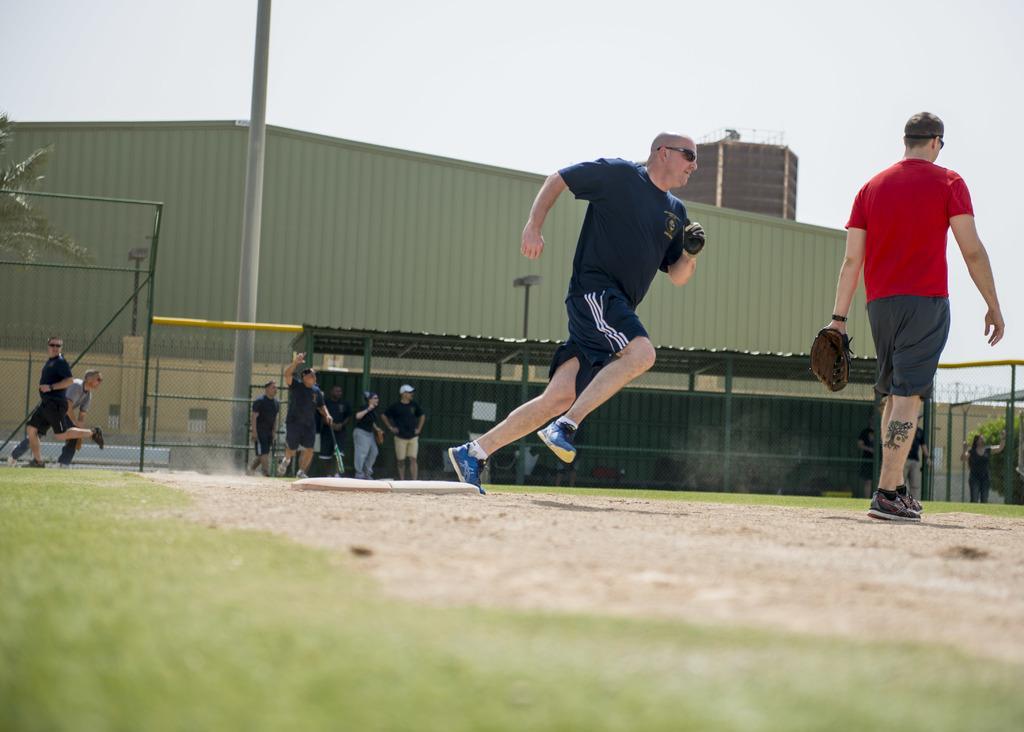How would you summarize this image in a sentence or two? In this picture I can observe a man running in the middle of the picture. On the right side I can observe a man walking on the land. In the background there are some people standing. I can observe a pole on the left side. In the background I can observe a sky. 